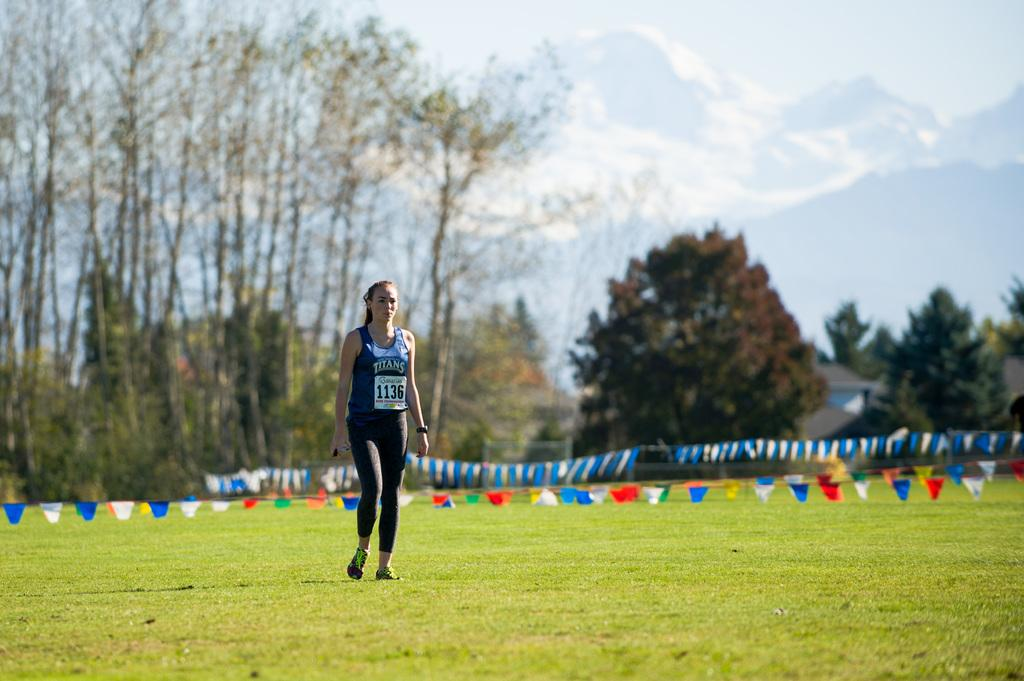<image>
Write a terse but informative summary of the picture. A woman in a Titans tank top walks across a field. 